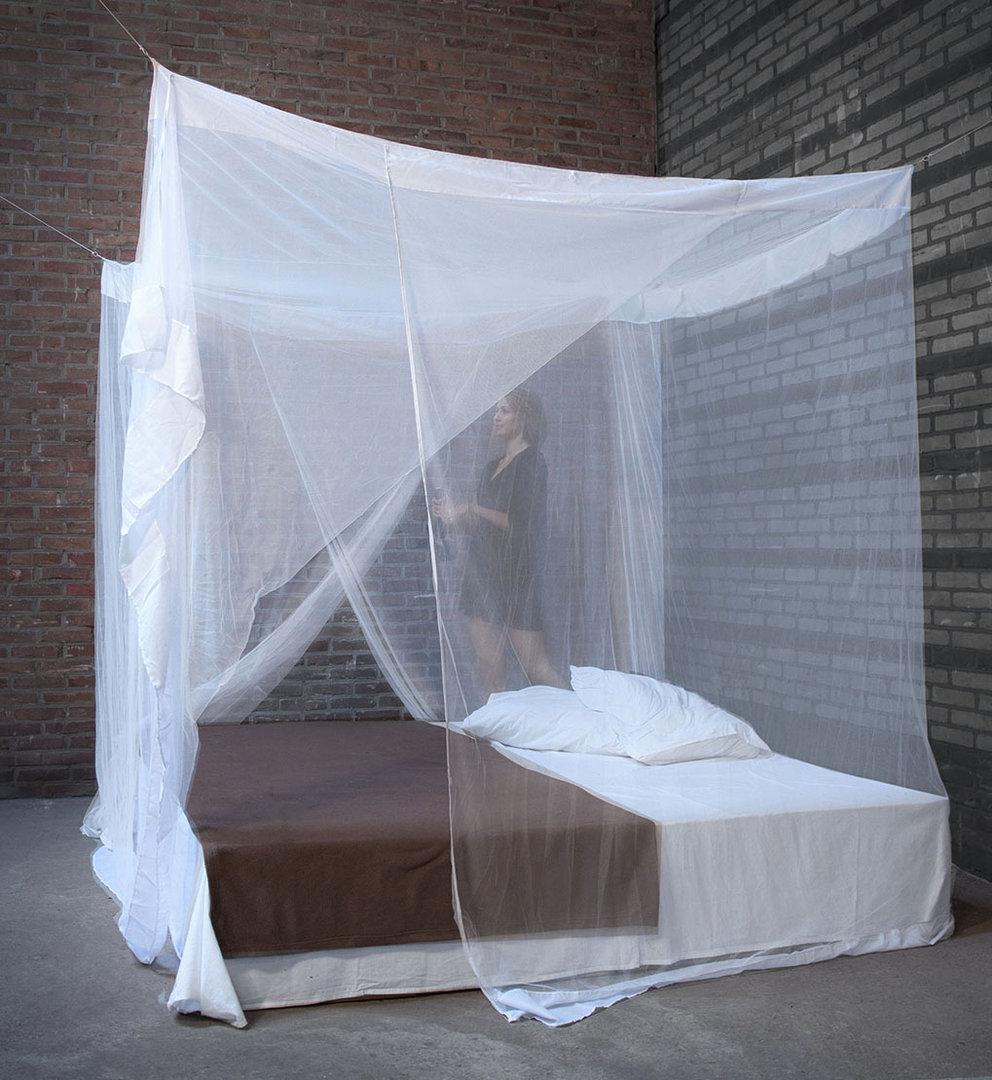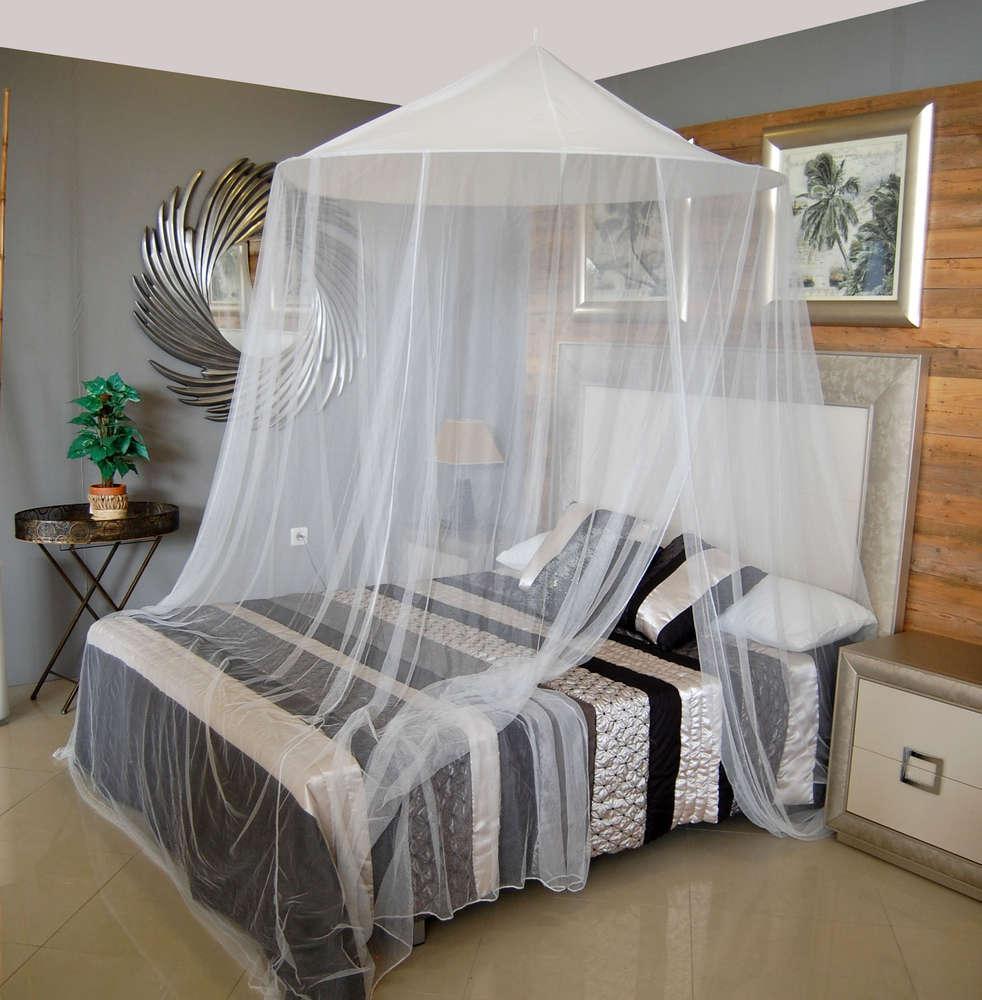The first image is the image on the left, the second image is the image on the right. Given the left and right images, does the statement "There is exactly one round canopy." hold true? Answer yes or no. Yes. The first image is the image on the left, the second image is the image on the right. Analyze the images presented: Is the assertion "The left and right image contains the same number of canopies one circle and one square." valid? Answer yes or no. Yes. 